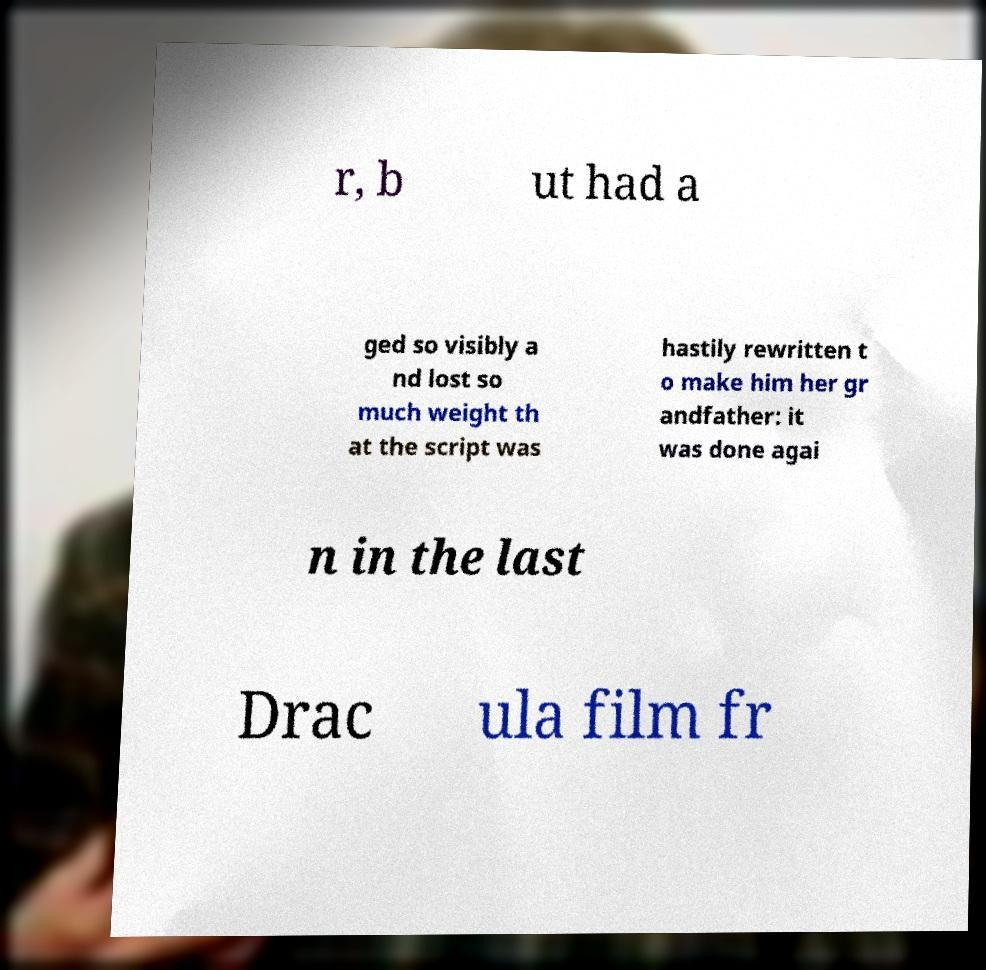What messages or text are displayed in this image? I need them in a readable, typed format. r, b ut had a ged so visibly a nd lost so much weight th at the script was hastily rewritten t o make him her gr andfather: it was done agai n in the last Drac ula film fr 